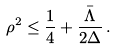Convert formula to latex. <formula><loc_0><loc_0><loc_500><loc_500>\rho ^ { 2 } \leq \frac { 1 } { 4 } + \frac { \bar { \Lambda } } { 2 \Delta } \, .</formula> 